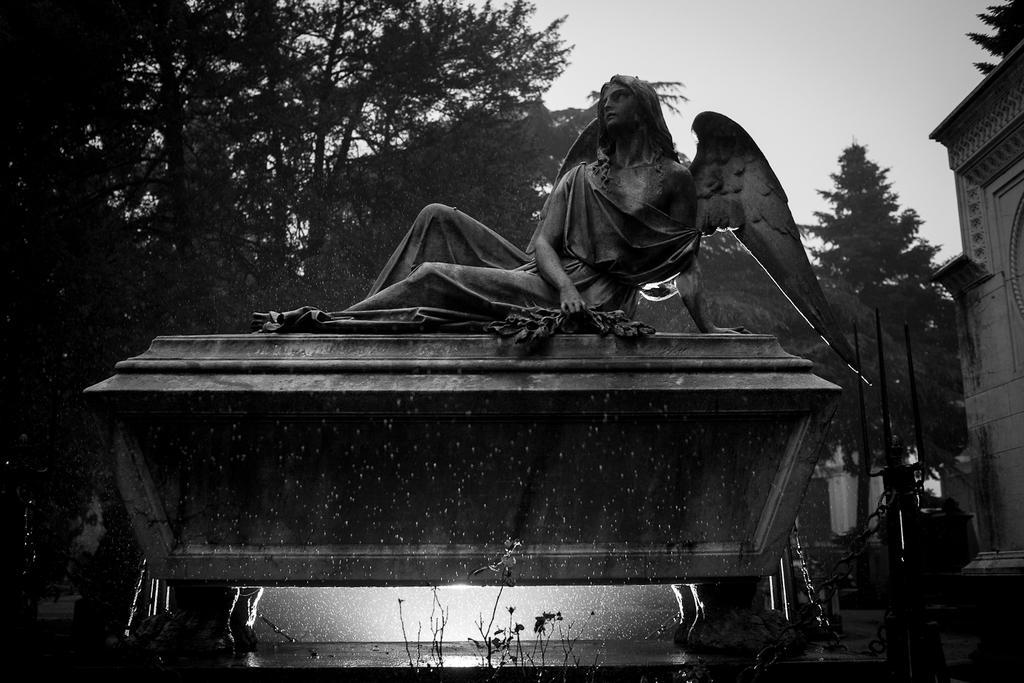How would you summarize this image in a sentence or two? In this image I see a sculpture and in the background I see a number of trees, sky and a wall. 